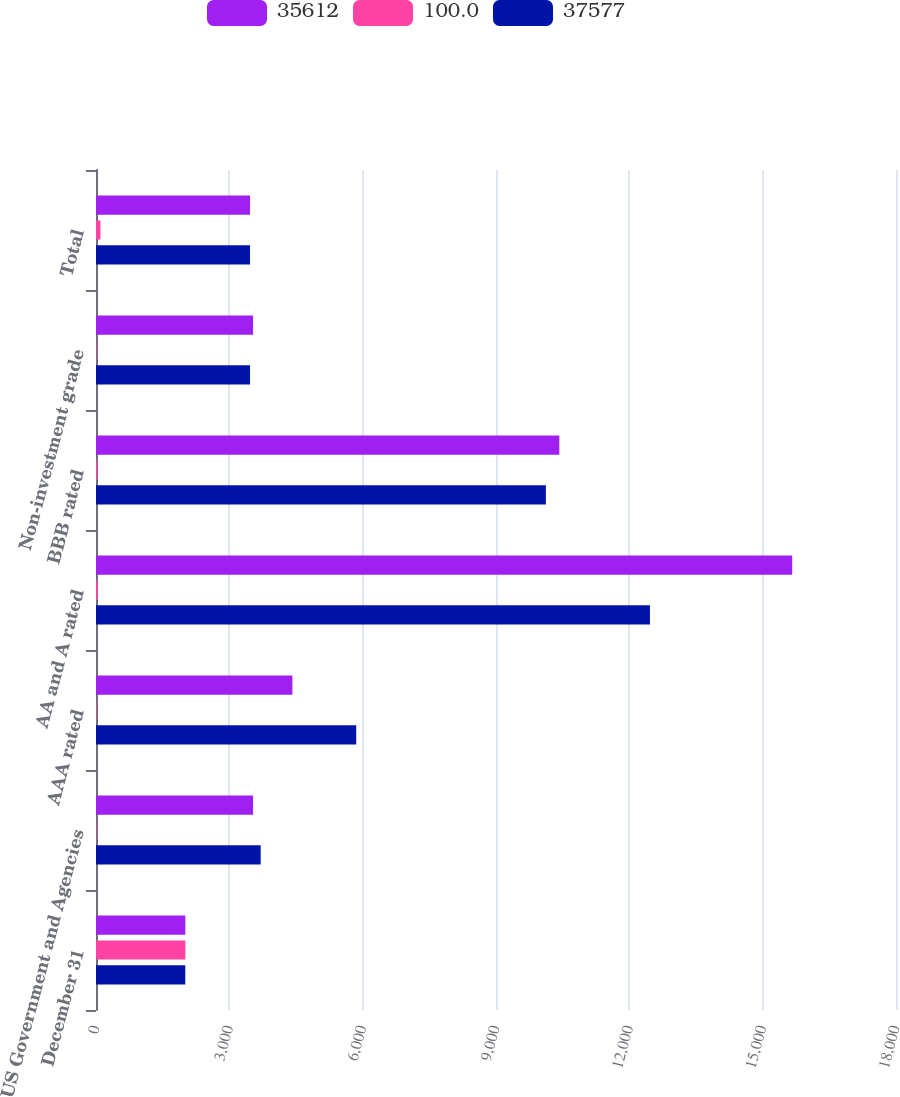<chart> <loc_0><loc_0><loc_500><loc_500><stacked_bar_chart><ecel><fcel>December 31<fcel>US Government and Agencies<fcel>AAA rated<fcel>AA and A rated<fcel>BBB rated<fcel>Non-investment grade<fcel>Total<nl><fcel>35612<fcel>2010<fcel>3534<fcel>4419<fcel>15665<fcel>10425<fcel>3534<fcel>3466<nl><fcel>100<fcel>2010<fcel>9.4<fcel>11.8<fcel>41.7<fcel>27.7<fcel>9.4<fcel>100<nl><fcel>37577<fcel>2009<fcel>3705<fcel>5855<fcel>12464<fcel>10122<fcel>3466<fcel>3466<nl></chart> 